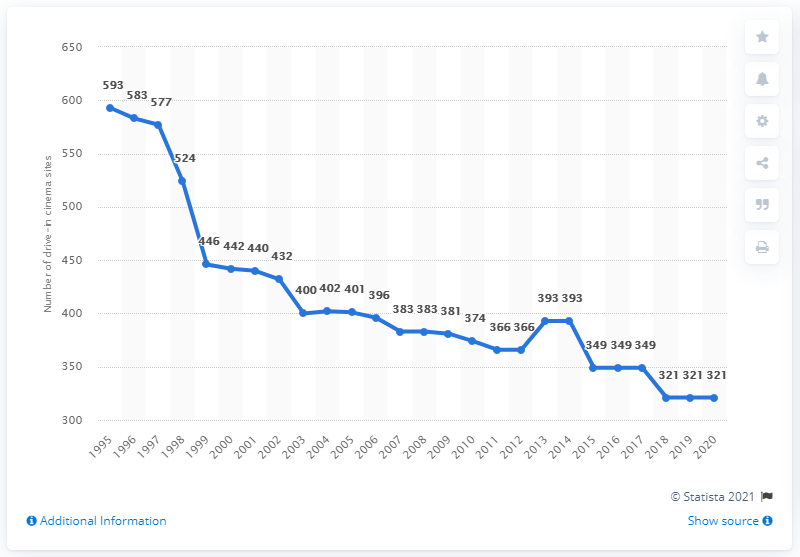Point out several critical features in this image. There were 321 drive-in cinema sites in the United States in 2020. 